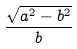Convert formula to latex. <formula><loc_0><loc_0><loc_500><loc_500>\frac { \sqrt { a ^ { 2 } - b ^ { 2 } } } { b }</formula> 